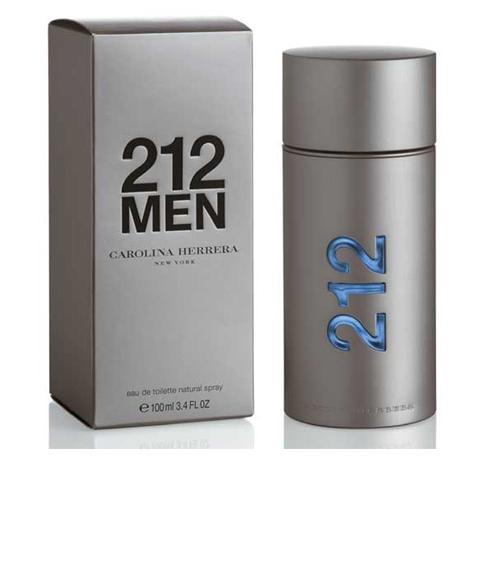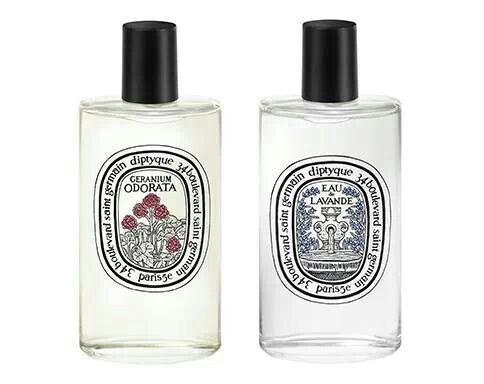The first image is the image on the left, the second image is the image on the right. Considering the images on both sides, is "One image shows a container of perfume and the box it is sold in, while a second image shows two or more bottles of cologne arranged side by side." valid? Answer yes or no. Yes. The first image is the image on the left, the second image is the image on the right. Assess this claim about the two images: "At least one image contains a richly colored glass bottle with a sculpted shape.". Correct or not? Answer yes or no. No. 